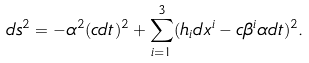Convert formula to latex. <formula><loc_0><loc_0><loc_500><loc_500>d s ^ { 2 } = - \alpha ^ { 2 } ( c d t ) ^ { 2 } + \sum _ { i = 1 } ^ { 3 } ( h _ { i } d x ^ { i } - c \beta ^ { i } \alpha d t ) ^ { 2 } .</formula> 